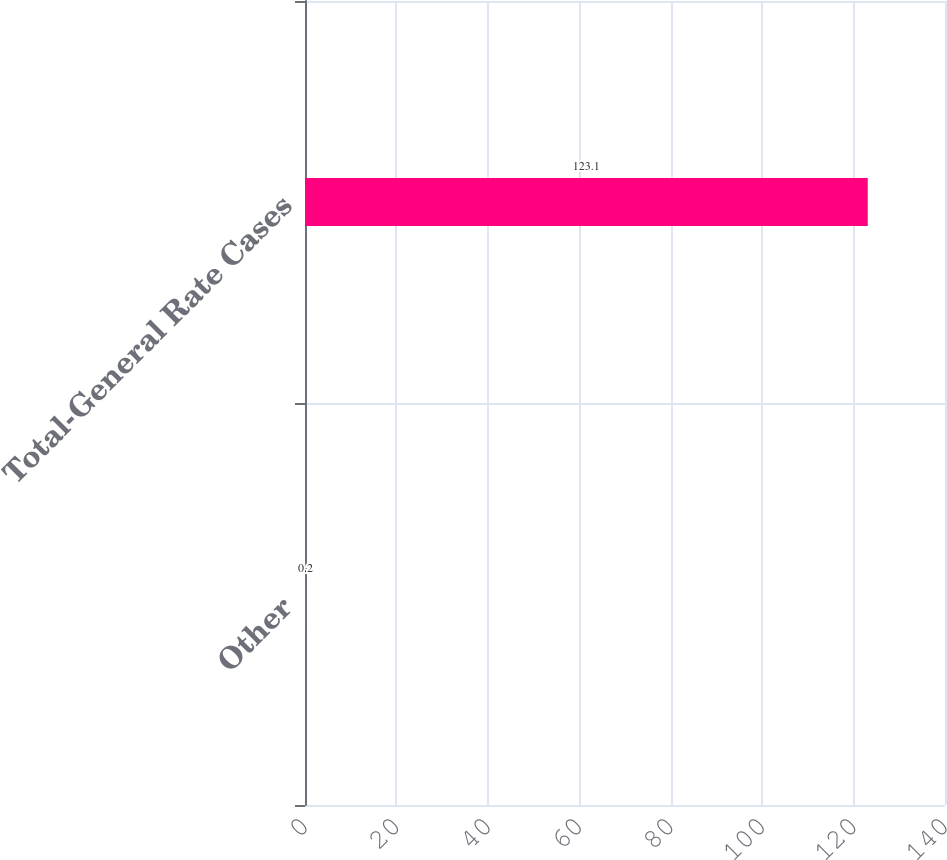<chart> <loc_0><loc_0><loc_500><loc_500><bar_chart><fcel>Other<fcel>Total-General Rate Cases<nl><fcel>0.2<fcel>123.1<nl></chart> 